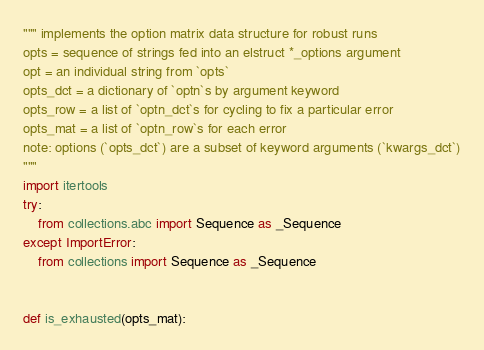<code> <loc_0><loc_0><loc_500><loc_500><_Python_>""" implements the option matrix data structure for robust runs
opts = sequence of strings fed into an elstruct *_options argument
opt = an individual string from `opts`
opts_dct = a dictionary of `optn`s by argument keyword
opts_row = a list of `optn_dct`s for cycling to fix a particular error
opts_mat = a list of `optn_row`s for each error
note: options (`opts_dct`) are a subset of keyword arguments (`kwargs_dct`)
"""
import itertools
try:
    from collections.abc import Sequence as _Sequence
except ImportError:
    from collections import Sequence as _Sequence


def is_exhausted(opts_mat):</code> 